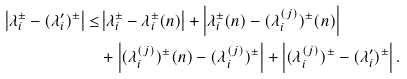<formula> <loc_0><loc_0><loc_500><loc_500>\left | \lambda _ { i } ^ { \pm } - ( \lambda _ { i } ^ { \prime } ) ^ { \pm } \right | \leq & \left | \lambda _ { i } ^ { \pm } - \lambda _ { i } ^ { \pm } ( n ) \right | + \left | \lambda _ { i } ^ { \pm } ( n ) - ( \lambda _ { i } ^ { ( j ) } ) ^ { \pm } ( n ) \right | \\ & + \left | ( \lambda _ { i } ^ { ( j ) } ) ^ { \pm } ( n ) - ( \lambda _ { i } ^ { ( j ) } ) ^ { \pm } \right | + \left | ( \lambda _ { i } ^ { ( j ) } ) ^ { \pm } - ( \lambda _ { i } ^ { \prime } ) ^ { \pm } \right | .</formula> 